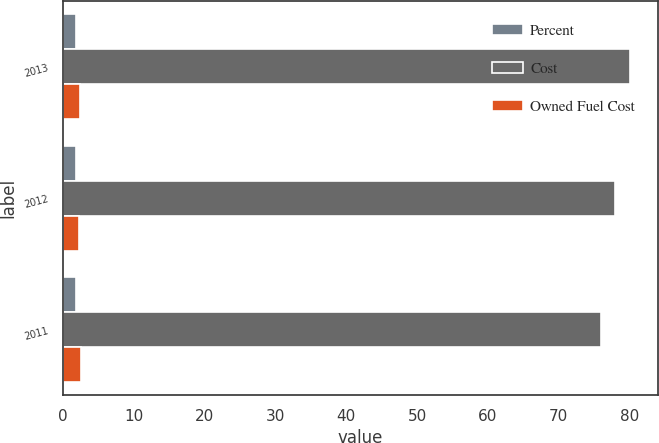Convert chart. <chart><loc_0><loc_0><loc_500><loc_500><stacked_bar_chart><ecel><fcel>2013<fcel>2012<fcel>2011<nl><fcel>Percent<fcel>1.84<fcel>1.77<fcel>1.77<nl><fcel>Cost<fcel>80<fcel>78<fcel>76<nl><fcel>Owned Fuel Cost<fcel>2.45<fcel>2.31<fcel>2.54<nl></chart> 